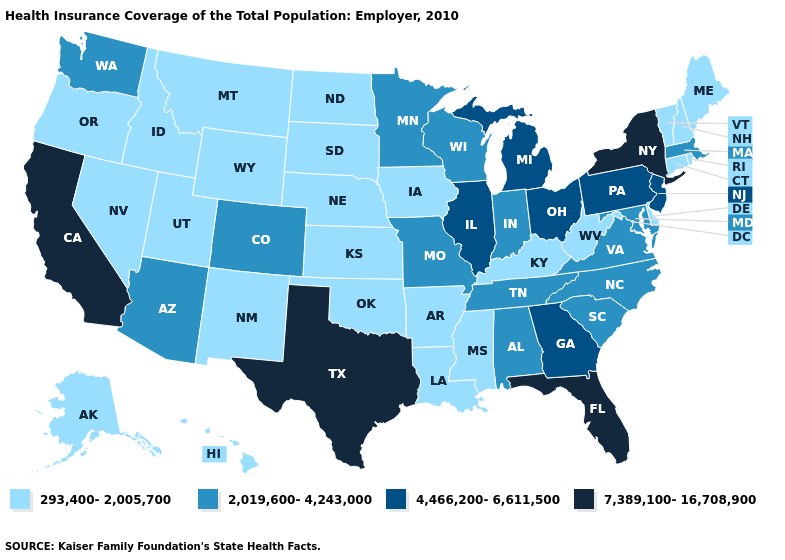Among the states that border Wisconsin , which have the highest value?
Be succinct. Illinois, Michigan. What is the value of South Dakota?
Answer briefly. 293,400-2,005,700. Name the states that have a value in the range 293,400-2,005,700?
Answer briefly. Alaska, Arkansas, Connecticut, Delaware, Hawaii, Idaho, Iowa, Kansas, Kentucky, Louisiana, Maine, Mississippi, Montana, Nebraska, Nevada, New Hampshire, New Mexico, North Dakota, Oklahoma, Oregon, Rhode Island, South Dakota, Utah, Vermont, West Virginia, Wyoming. Which states have the lowest value in the South?
Write a very short answer. Arkansas, Delaware, Kentucky, Louisiana, Mississippi, Oklahoma, West Virginia. What is the value of Delaware?
Answer briefly. 293,400-2,005,700. Does Texas have a lower value than Iowa?
Short answer required. No. Does West Virginia have the same value as Pennsylvania?
Concise answer only. No. Does Minnesota have the lowest value in the MidWest?
Give a very brief answer. No. What is the value of Minnesota?
Write a very short answer. 2,019,600-4,243,000. What is the value of North Dakota?
Keep it brief. 293,400-2,005,700. What is the highest value in states that border Montana?
Short answer required. 293,400-2,005,700. What is the value of Alaska?
Be succinct. 293,400-2,005,700. Does Oregon have the same value as West Virginia?
Quick response, please. Yes. What is the value of Georgia?
Be succinct. 4,466,200-6,611,500. What is the value of Louisiana?
Give a very brief answer. 293,400-2,005,700. 